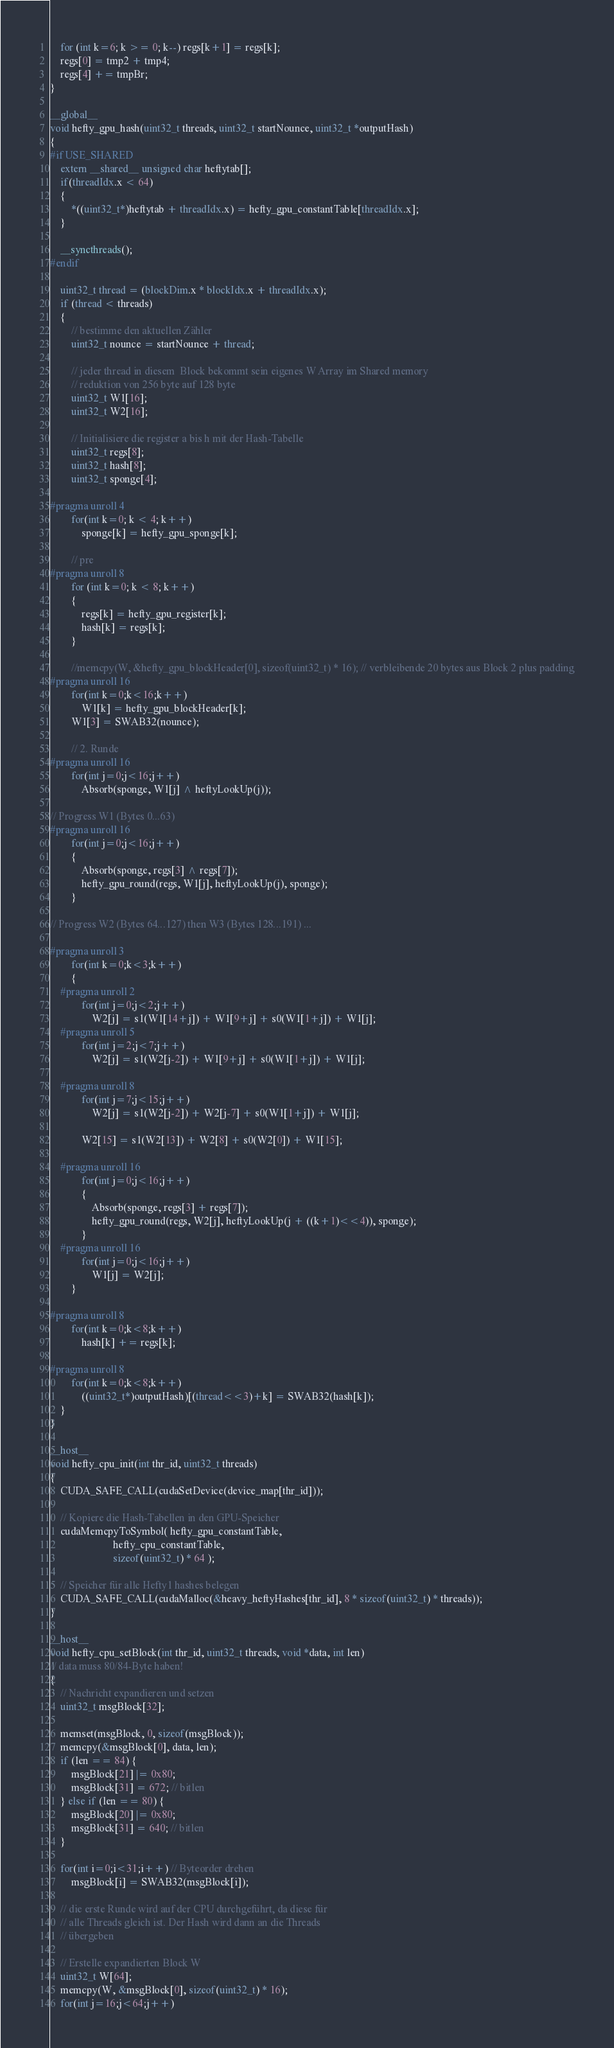Convert code to text. <code><loc_0><loc_0><loc_500><loc_500><_Cuda_>    for (int k=6; k >= 0; k--) regs[k+1] = regs[k];
    regs[0] = tmp2 + tmp4;
    regs[4] += tmpBr;
}

__global__
void hefty_gpu_hash(uint32_t threads, uint32_t startNounce, uint32_t *outputHash)
{
#if USE_SHARED
    extern __shared__ unsigned char heftytab[];
    if(threadIdx.x < 64)
    {
        *((uint32_t*)heftytab + threadIdx.x) = hefty_gpu_constantTable[threadIdx.x];
    }

    __syncthreads();
#endif

    uint32_t thread = (blockDim.x * blockIdx.x + threadIdx.x);
    if (thread < threads)
    {
        // bestimme den aktuellen Zähler
        uint32_t nounce = startNounce + thread;

        // jeder thread in diesem  Block bekommt sein eigenes W Array im Shared memory
        // reduktion von 256 byte auf 128 byte
        uint32_t W1[16];
        uint32_t W2[16];

        // Initialisiere die register a bis h mit der Hash-Tabelle
        uint32_t regs[8];
        uint32_t hash[8];
        uint32_t sponge[4];

#pragma unroll 4
        for(int k=0; k < 4; k++)
            sponge[k] = hefty_gpu_sponge[k];

        // pre
#pragma unroll 8
        for (int k=0; k < 8; k++)
        {
            regs[k] = hefty_gpu_register[k];
            hash[k] = regs[k];
        }

        //memcpy(W, &hefty_gpu_blockHeader[0], sizeof(uint32_t) * 16); // verbleibende 20 bytes aus Block 2 plus padding
#pragma unroll 16
        for(int k=0;k<16;k++)
            W1[k] = hefty_gpu_blockHeader[k];
        W1[3] = SWAB32(nounce);

        // 2. Runde
#pragma unroll 16
        for(int j=0;j<16;j++)
            Absorb(sponge, W1[j] ^ heftyLookUp(j));

// Progress W1 (Bytes 0...63)
#pragma unroll 16
        for(int j=0;j<16;j++)
        {
            Absorb(sponge, regs[3] ^ regs[7]);
            hefty_gpu_round(regs, W1[j], heftyLookUp(j), sponge);
        }

// Progress W2 (Bytes 64...127) then W3 (Bytes 128...191) ...

#pragma unroll 3
        for(int k=0;k<3;k++)
        {
    #pragma unroll 2
            for(int j=0;j<2;j++)
                W2[j] = s1(W1[14+j]) + W1[9+j] + s0(W1[1+j]) + W1[j];
    #pragma unroll 5
            for(int j=2;j<7;j++)
                W2[j] = s1(W2[j-2]) + W1[9+j] + s0(W1[1+j]) + W1[j];

    #pragma unroll 8
            for(int j=7;j<15;j++)
                W2[j] = s1(W2[j-2]) + W2[j-7] + s0(W1[1+j]) + W1[j];

            W2[15] = s1(W2[13]) + W2[8] + s0(W2[0]) + W1[15];

    #pragma unroll 16
            for(int j=0;j<16;j++)
            {
                Absorb(sponge, regs[3] + regs[7]);
                hefty_gpu_round(regs, W2[j], heftyLookUp(j + ((k+1)<<4)), sponge);
            }
    #pragma unroll 16
            for(int j=0;j<16;j++)
                W1[j] = W2[j];
        }

#pragma unroll 8
        for(int k=0;k<8;k++)
            hash[k] += regs[k];

#pragma unroll 8
        for(int k=0;k<8;k++)
            ((uint32_t*)outputHash)[(thread<<3)+k] = SWAB32(hash[k]);
    }
}

__host__
void hefty_cpu_init(int thr_id, uint32_t threads)
{
    CUDA_SAFE_CALL(cudaSetDevice(device_map[thr_id]));

    // Kopiere die Hash-Tabellen in den GPU-Speicher
    cudaMemcpyToSymbol( hefty_gpu_constantTable,
                        hefty_cpu_constantTable,
                        sizeof(uint32_t) * 64 );

    // Speicher für alle Hefty1 hashes belegen
    CUDA_SAFE_CALL(cudaMalloc(&heavy_heftyHashes[thr_id], 8 * sizeof(uint32_t) * threads));
}

__host__
void hefty_cpu_setBlock(int thr_id, uint32_t threads, void *data, int len)
// data muss 80/84-Byte haben!
{
    // Nachricht expandieren und setzen
    uint32_t msgBlock[32];

    memset(msgBlock, 0, sizeof(msgBlock));
    memcpy(&msgBlock[0], data, len);
    if (len == 84) {
        msgBlock[21] |= 0x80;
        msgBlock[31] = 672; // bitlen
    } else if (len == 80) {
        msgBlock[20] |= 0x80;
        msgBlock[31] = 640; // bitlen
    }

    for(int i=0;i<31;i++) // Byteorder drehen
        msgBlock[i] = SWAB32(msgBlock[i]);

    // die erste Runde wird auf der CPU durchgeführt, da diese für
    // alle Threads gleich ist. Der Hash wird dann an die Threads
    // übergeben

    // Erstelle expandierten Block W
    uint32_t W[64];
    memcpy(W, &msgBlock[0], sizeof(uint32_t) * 16);
    for(int j=16;j<64;j++)</code> 